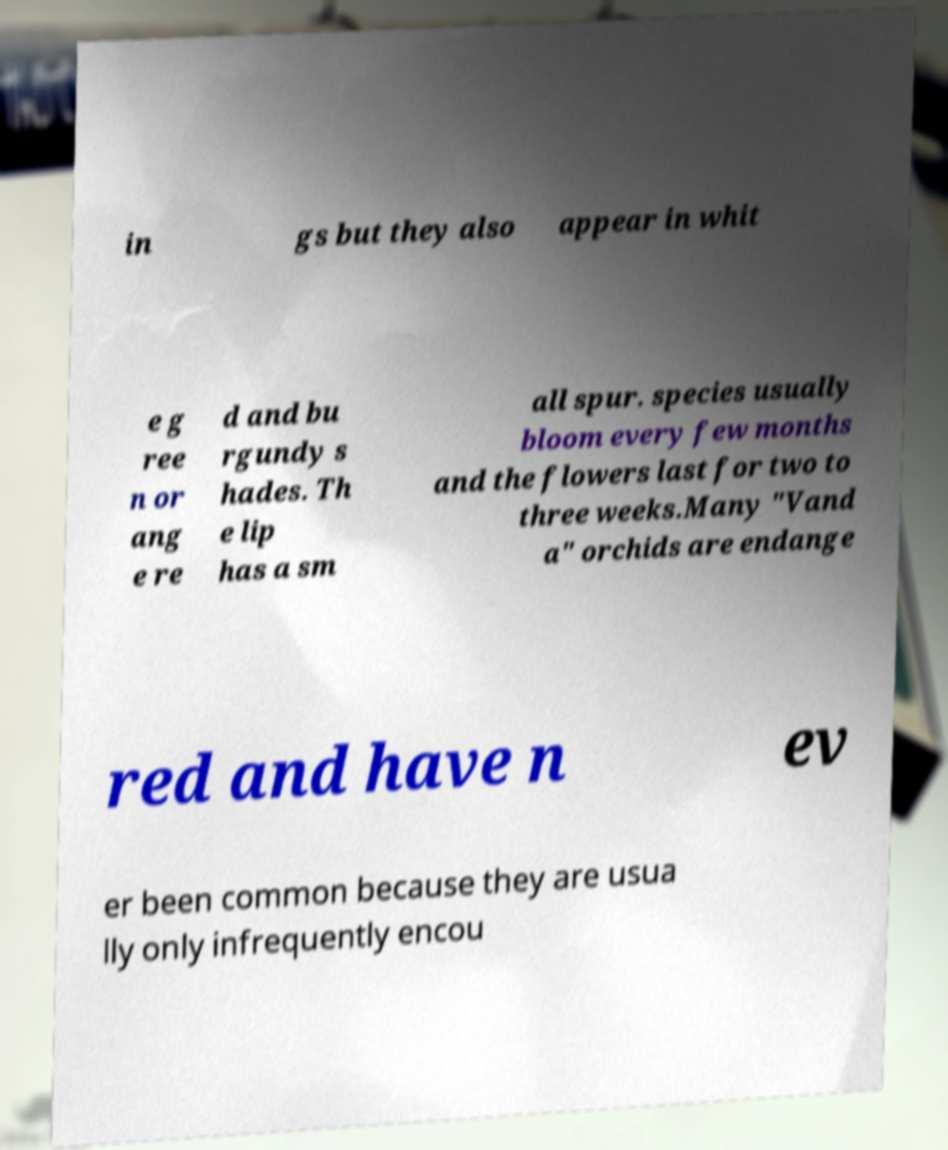Could you extract and type out the text from this image? in gs but they also appear in whit e g ree n or ang e re d and bu rgundy s hades. Th e lip has a sm all spur. species usually bloom every few months and the flowers last for two to three weeks.Many "Vand a" orchids are endange red and have n ev er been common because they are usua lly only infrequently encou 